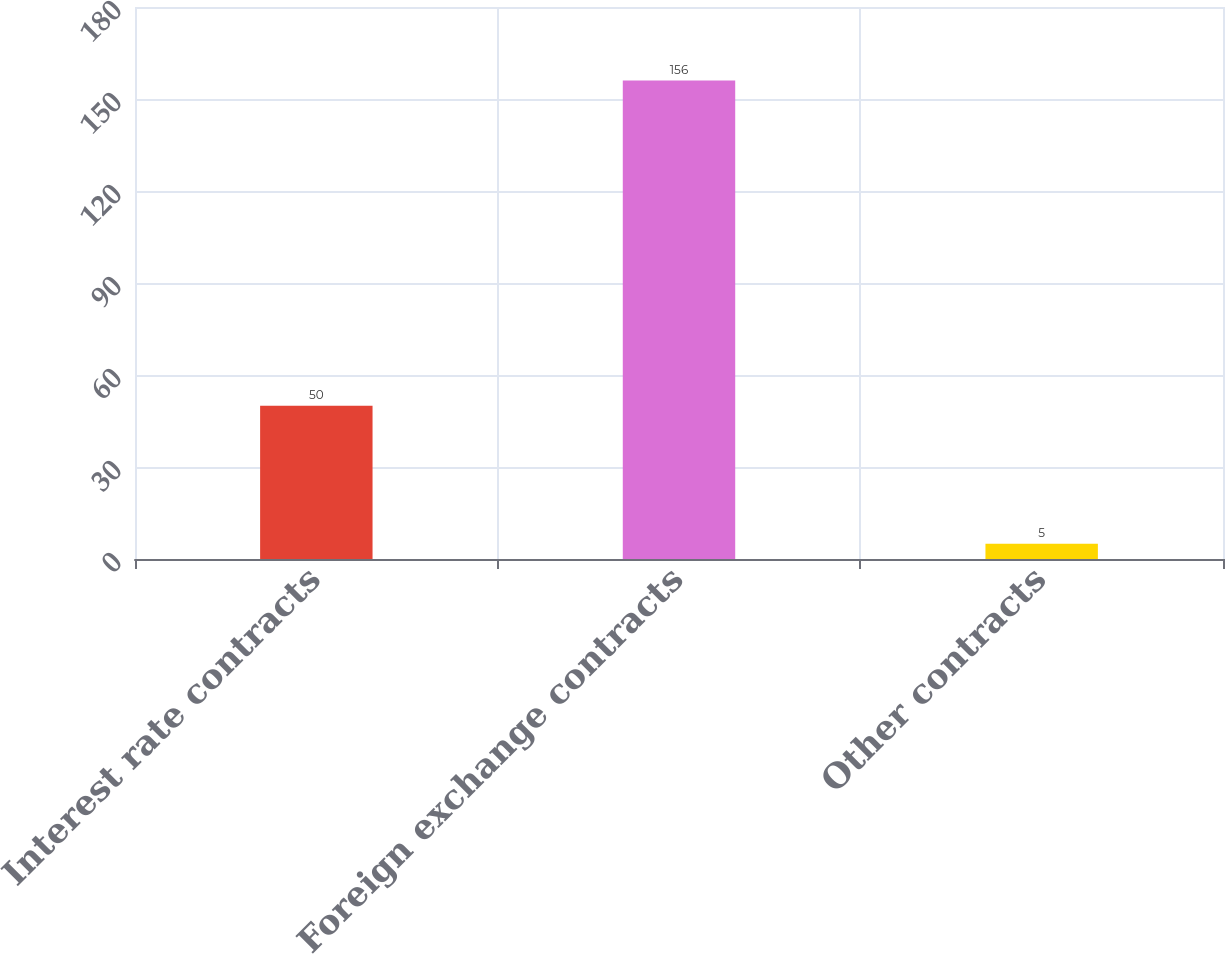Convert chart. <chart><loc_0><loc_0><loc_500><loc_500><bar_chart><fcel>Interest rate contracts<fcel>Foreign exchange contracts<fcel>Other contracts<nl><fcel>50<fcel>156<fcel>5<nl></chart> 